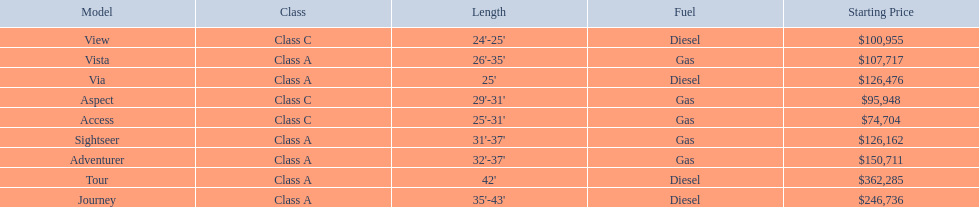Which model has the lowest started price? Access. I'm looking to parse the entire table for insights. Could you assist me with that? {'header': ['Model', 'Class', 'Length', 'Fuel', 'Starting Price'], 'rows': [['View', 'Class C', "24'-25'", 'Diesel', '$100,955'], ['Vista', 'Class A', "26'-35'", 'Gas', '$107,717'], ['Via', 'Class A', "25'", 'Diesel', '$126,476'], ['Aspect', 'Class C', "29'-31'", 'Gas', '$95,948'], ['Access', 'Class C', "25'-31'", 'Gas', '$74,704'], ['Sightseer', 'Class A', "31'-37'", 'Gas', '$126,162'], ['Adventurer', 'Class A', "32'-37'", 'Gas', '$150,711'], ['Tour', 'Class A', "42'", 'Diesel', '$362,285'], ['Journey', 'Class A', "35'-43'", 'Diesel', '$246,736']]} 